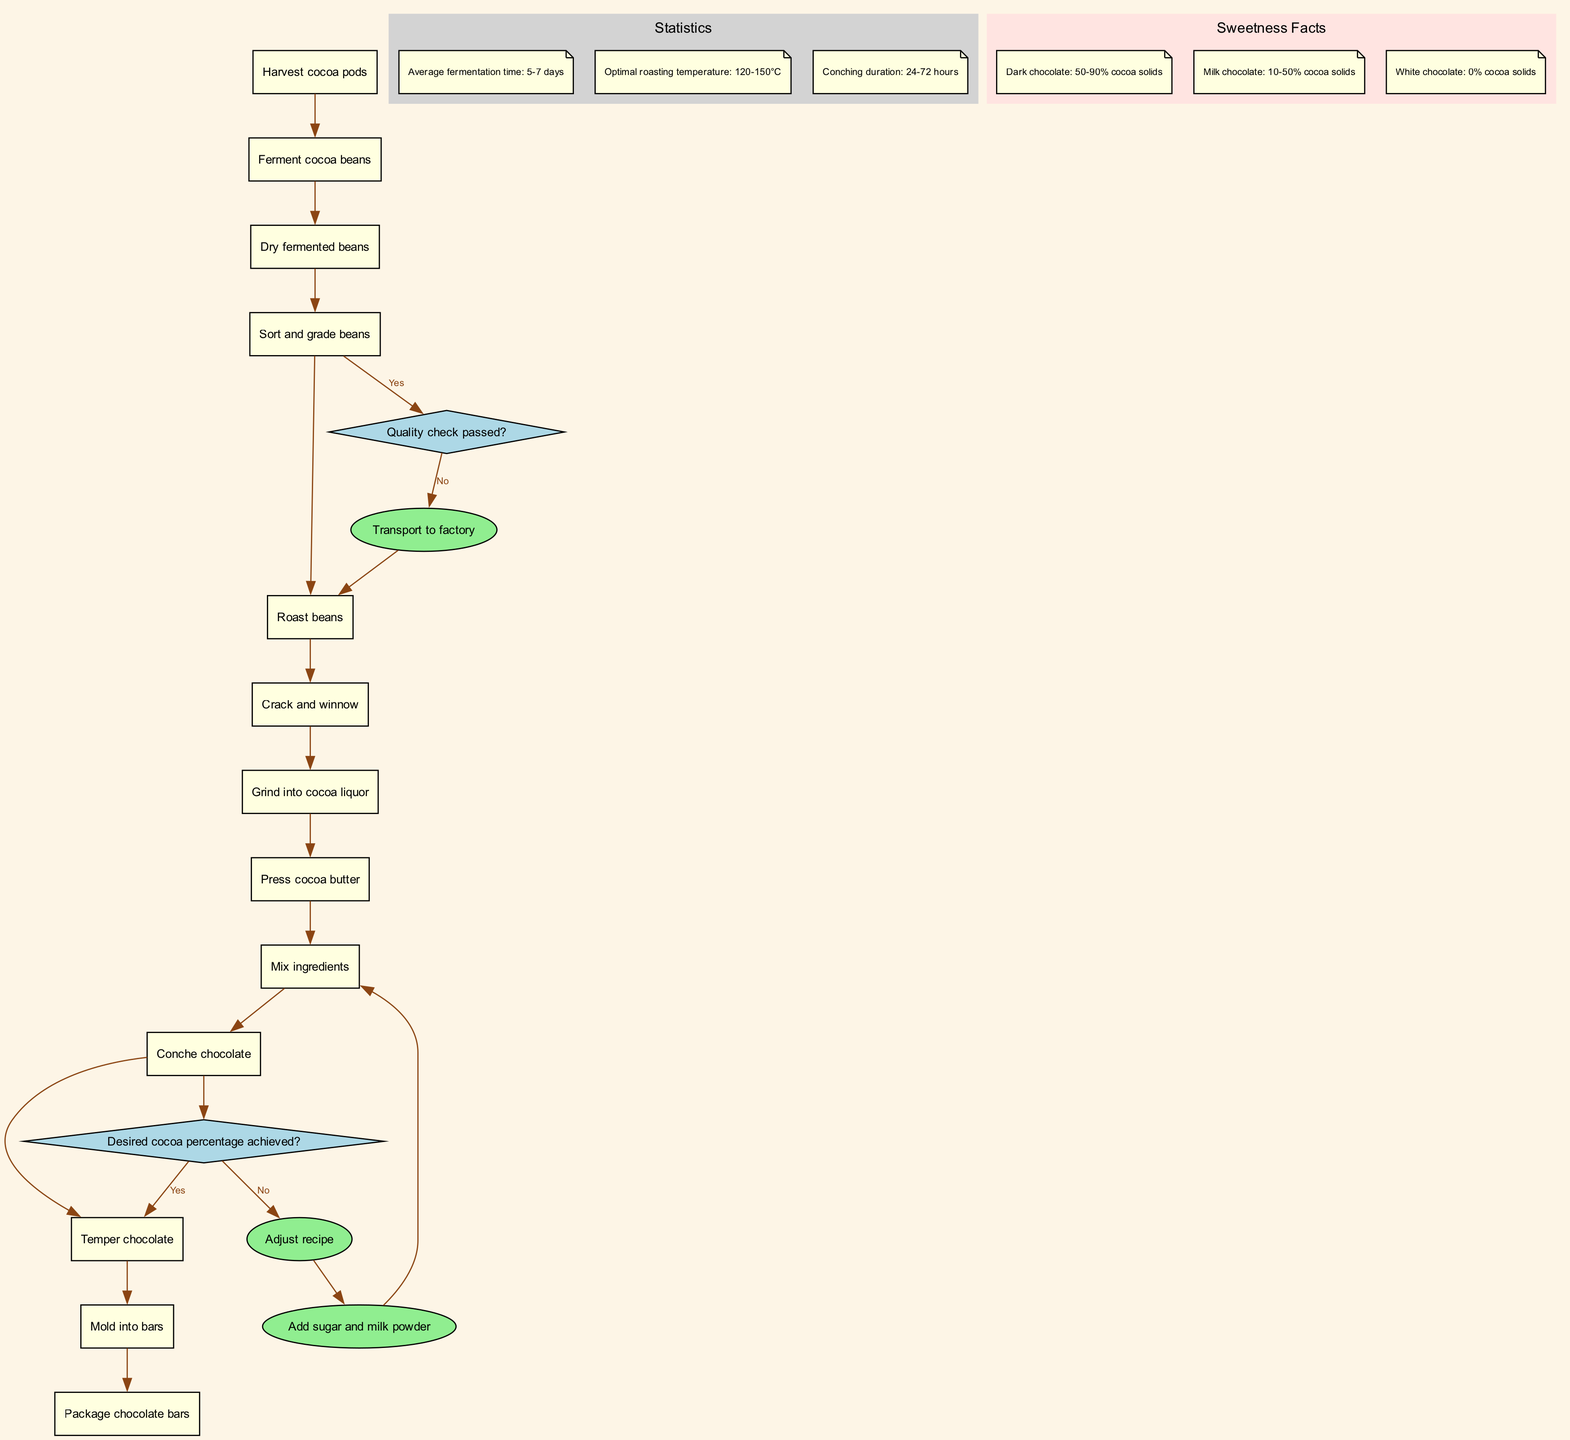What is the first activity in the cocoa bean journey? The diagram shows the first activity as "Harvest cocoa pods." By identifying the top node in the activity list, we see it is the initial step.
Answer: Harvest cocoa pods How many activities are involved in the cocoa bean journey? Counting the activities listed in the diagram reveals there are 13 individual activities contributing to the process as shown.
Answer: 13 What decision comes after sorting and grading beans? The diagram outlines that after the activity "Sort and grade beans," the subsequent decision is "Quality check passed?" This can be traced directly down the flow from the sorting activity.
Answer: Quality check passed? What happens if the quality check fails? According to the diagram, if the quality check does not pass, the flow goes to the "Transport to factory" node, which acts as a path for re-assessment or further action.
Answer: Transport to factory What is the optimal roasting temperature? The statistics section of the diagram states the optimal roasting temperature is between 120-150°C, which can be found in the depicted statistics area.
Answer: 120-150°C What is done before grinding cocoa beans into liquor? The diagram indicates "Crack and winnow" is the step that precedes grinding the beans into cocoa liquor, showing the sequential nature of the activities in the workflow.
Answer: Crack and winnow How long does conching take? The statistics provided in the diagram specify that the conching duration ranges from 24 to 72 hours, present in the statistical information section.
Answer: 24-72 hours What ingredient is added after tempering chocolate? According to the flow of the process, the next step after "Temper chocolate" is "Mold into bars," which follows directly in the sequence of activities.
Answer: Mold into bars What is the starting point of this cocoa production process? The diagram clearly identifies "Harvest cocoa pods" as the starting point in the activity flow, marking the initiation of the production journey.
Answer: Harvest cocoa pods 